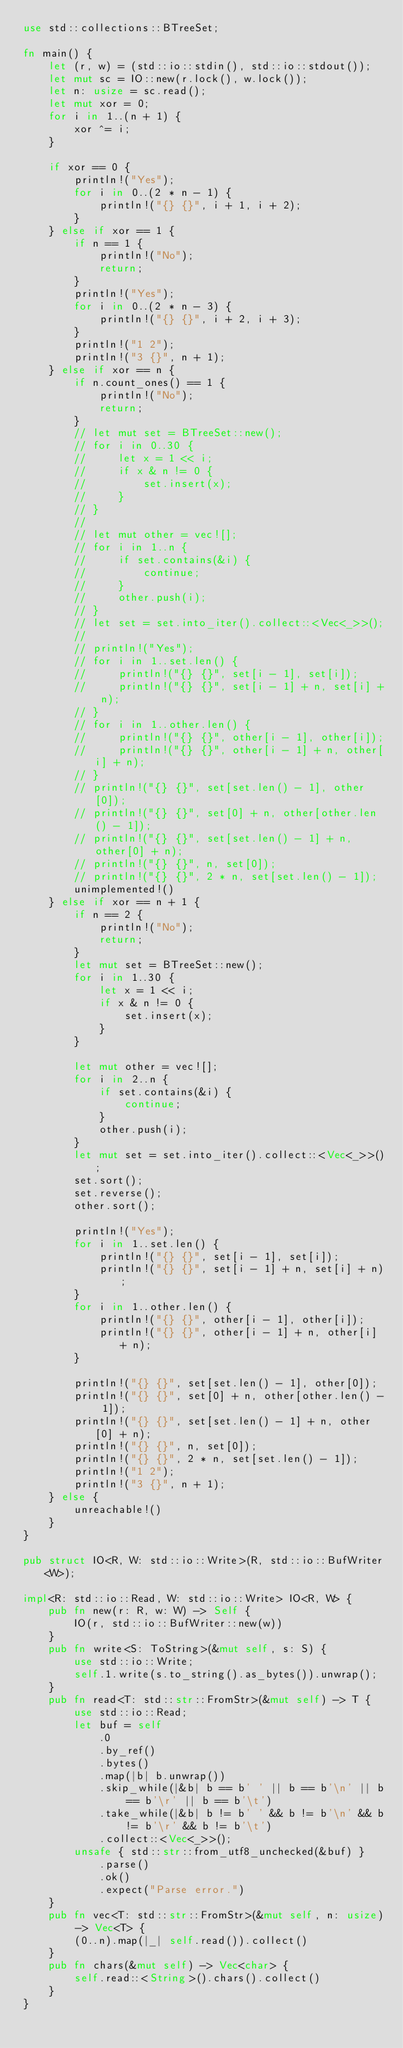<code> <loc_0><loc_0><loc_500><loc_500><_Rust_>use std::collections::BTreeSet;

fn main() {
    let (r, w) = (std::io::stdin(), std::io::stdout());
    let mut sc = IO::new(r.lock(), w.lock());
    let n: usize = sc.read();
    let mut xor = 0;
    for i in 1..(n + 1) {
        xor ^= i;
    }

    if xor == 0 {
        println!("Yes");
        for i in 0..(2 * n - 1) {
            println!("{} {}", i + 1, i + 2);
        }
    } else if xor == 1 {
        if n == 1 {
            println!("No");
            return;
        }
        println!("Yes");
        for i in 0..(2 * n - 3) {
            println!("{} {}", i + 2, i + 3);
        }
        println!("1 2");
        println!("3 {}", n + 1);
    } else if xor == n {
        if n.count_ones() == 1 {
            println!("No");
            return;
        }
        // let mut set = BTreeSet::new();
        // for i in 0..30 {
        //     let x = 1 << i;
        //     if x & n != 0 {
        //         set.insert(x);
        //     }
        // }
        //
        // let mut other = vec![];
        // for i in 1..n {
        //     if set.contains(&i) {
        //         continue;
        //     }
        //     other.push(i);
        // }
        // let set = set.into_iter().collect::<Vec<_>>();
        //
        // println!("Yes");
        // for i in 1..set.len() {
        //     println!("{} {}", set[i - 1], set[i]);
        //     println!("{} {}", set[i - 1] + n, set[i] + n);
        // }
        // for i in 1..other.len() {
        //     println!("{} {}", other[i - 1], other[i]);
        //     println!("{} {}", other[i - 1] + n, other[i] + n);
        // }
        // println!("{} {}", set[set.len() - 1], other[0]);
        // println!("{} {}", set[0] + n, other[other.len() - 1]);
        // println!("{} {}", set[set.len() - 1] + n, other[0] + n);
        // println!("{} {}", n, set[0]);
        // println!("{} {}", 2 * n, set[set.len() - 1]);
        unimplemented!()
    } else if xor == n + 1 {
        if n == 2 {
            println!("No");
            return;
        }
        let mut set = BTreeSet::new();
        for i in 1..30 {
            let x = 1 << i;
            if x & n != 0 {
                set.insert(x);
            }
        }

        let mut other = vec![];
        for i in 2..n {
            if set.contains(&i) {
                continue;
            }
            other.push(i);
        }
        let mut set = set.into_iter().collect::<Vec<_>>();
        set.sort();
        set.reverse();
        other.sort();

        println!("Yes");
        for i in 1..set.len() {
            println!("{} {}", set[i - 1], set[i]);
            println!("{} {}", set[i - 1] + n, set[i] + n);
        }
        for i in 1..other.len() {
            println!("{} {}", other[i - 1], other[i]);
            println!("{} {}", other[i - 1] + n, other[i] + n);
        }

        println!("{} {}", set[set.len() - 1], other[0]);
        println!("{} {}", set[0] + n, other[other.len() - 1]);
        println!("{} {}", set[set.len() - 1] + n, other[0] + n);
        println!("{} {}", n, set[0]);
        println!("{} {}", 2 * n, set[set.len() - 1]);
        println!("1 2");
        println!("3 {}", n + 1);
    } else {
        unreachable!()
    }
}

pub struct IO<R, W: std::io::Write>(R, std::io::BufWriter<W>);

impl<R: std::io::Read, W: std::io::Write> IO<R, W> {
    pub fn new(r: R, w: W) -> Self {
        IO(r, std::io::BufWriter::new(w))
    }
    pub fn write<S: ToString>(&mut self, s: S) {
        use std::io::Write;
        self.1.write(s.to_string().as_bytes()).unwrap();
    }
    pub fn read<T: std::str::FromStr>(&mut self) -> T {
        use std::io::Read;
        let buf = self
            .0
            .by_ref()
            .bytes()
            .map(|b| b.unwrap())
            .skip_while(|&b| b == b' ' || b == b'\n' || b == b'\r' || b == b'\t')
            .take_while(|&b| b != b' ' && b != b'\n' && b != b'\r' && b != b'\t')
            .collect::<Vec<_>>();
        unsafe { std::str::from_utf8_unchecked(&buf) }
            .parse()
            .ok()
            .expect("Parse error.")
    }
    pub fn vec<T: std::str::FromStr>(&mut self, n: usize) -> Vec<T> {
        (0..n).map(|_| self.read()).collect()
    }
    pub fn chars(&mut self) -> Vec<char> {
        self.read::<String>().chars().collect()
    }
}
</code> 